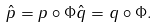<formula> <loc_0><loc_0><loc_500><loc_500>\hat { p } = p \circ \Phi \hat { q } = q \circ \Phi .</formula> 